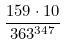Convert formula to latex. <formula><loc_0><loc_0><loc_500><loc_500>\frac { 1 5 9 \cdot 1 0 } { 3 6 3 ^ { 3 4 7 } }</formula> 